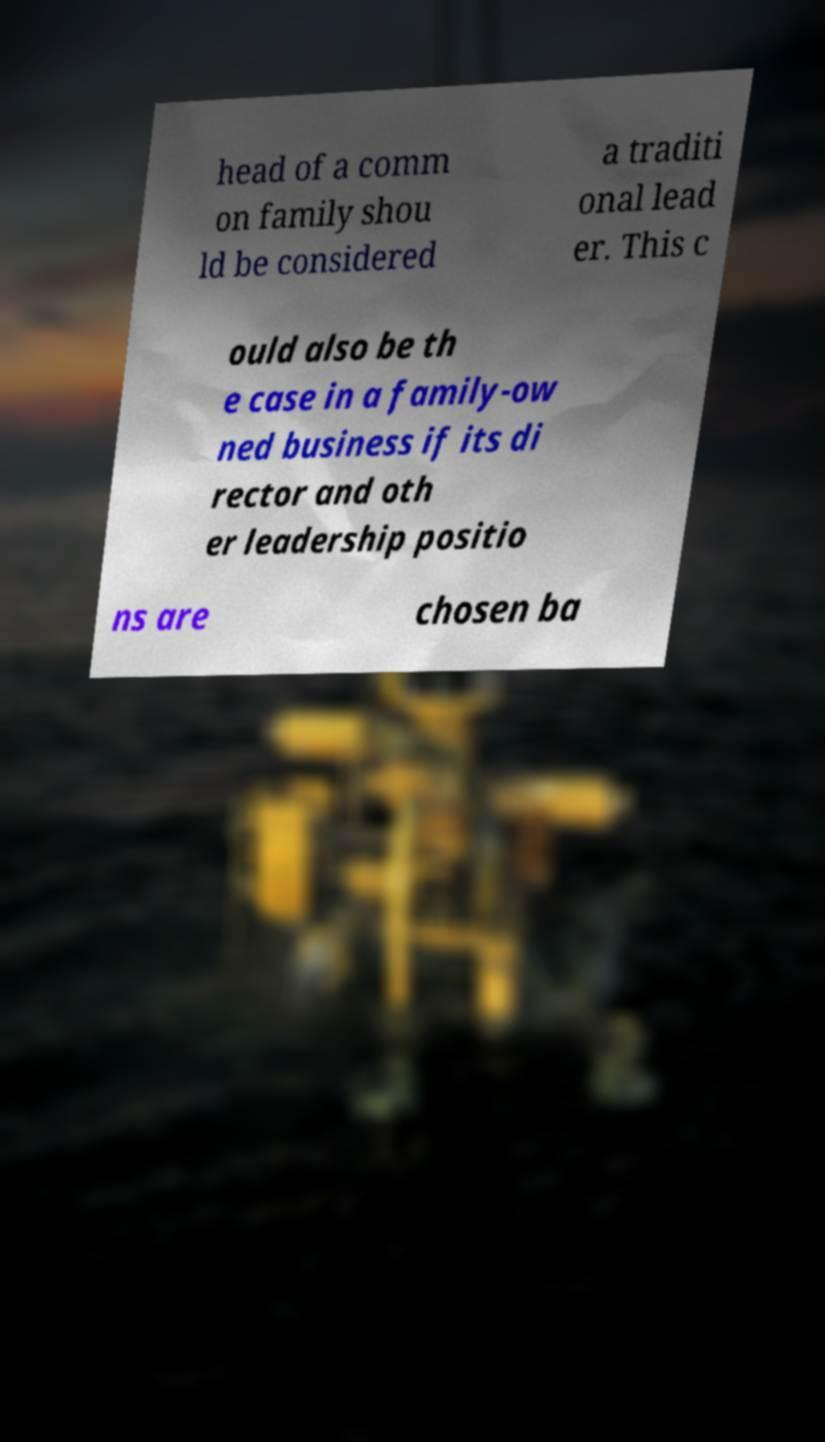I need the written content from this picture converted into text. Can you do that? head of a comm on family shou ld be considered a traditi onal lead er. This c ould also be th e case in a family-ow ned business if its di rector and oth er leadership positio ns are chosen ba 